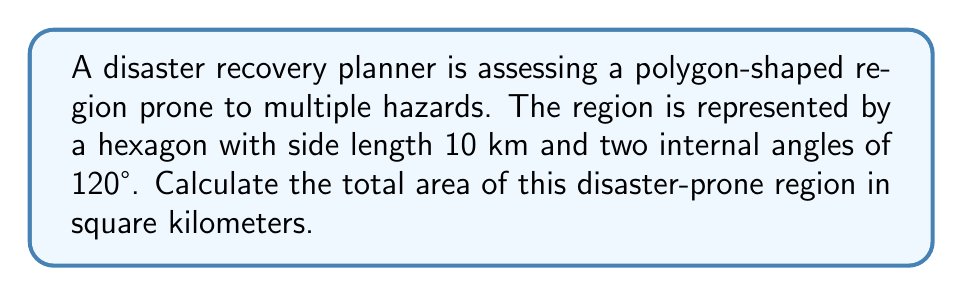Teach me how to tackle this problem. Let's approach this step-by-step:

1) First, we need to recognize that this hexagon is not regular, as only two angles are specified as 120°.

2) We can divide this hexagon into four triangles: two equilateral triangles (with 60° angles) and two isosceles triangles (with one 120° angle each).

3) For the equilateral triangles:
   - Side length = 10 km
   - Area of one equilateral triangle = $\frac{\sqrt{3}}{4}a^2$, where $a$ is the side length
   - Area = $\frac{\sqrt{3}}{4} \cdot 10^2 = 25\sqrt{3}$ km²

4) For the isosceles triangles:
   - Base = 10 km
   - Angle between equal sides = 120°
   - Height can be calculated using the formula: $h = a \cdot \sin(60°) = 10 \cdot \frac{\sqrt{3}}{2} = 5\sqrt{3}$ km
   - Area of one isosceles triangle = $\frac{1}{2} \cdot 10 \cdot 5\sqrt{3} = 25\sqrt{3}$ km²

5) Total area:
   - Area = 2 (area of equilateral triangle) + 2 (area of isosceles triangle)
   - Area = $2(25\sqrt{3}) + 2(25\sqrt{3}) = 100\sqrt{3}$ km²

[asy]
unitsize(10mm);
pair A = (0,0), B = (1,0), C = (2,0), D = (3,0), E = (1.5,0.866), F = (1.5,-0.866);
draw(A--B--C--D--E--F--cycle);
label("10 km", (A+B)/2, S);
label("120°", D, NE);
label("120°", A, NW);
[/asy]
Answer: $$100\sqrt{3}$$ km² 